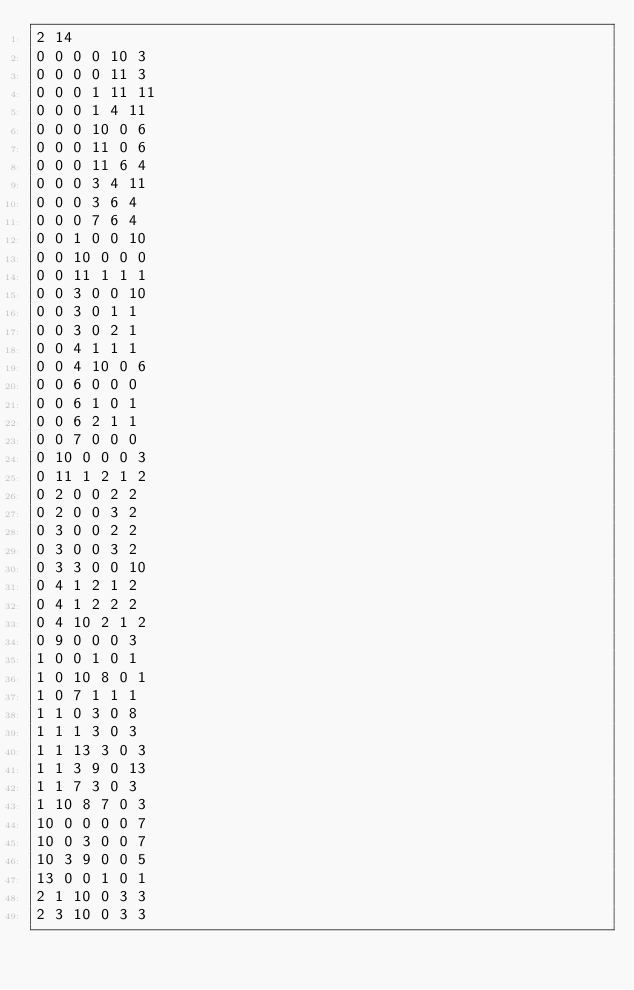<code> <loc_0><loc_0><loc_500><loc_500><_SQL_>2 14
0 0 0 0 10 3
0 0 0 0 11 3
0 0 0 1 11 11
0 0 0 1 4 11
0 0 0 10 0 6
0 0 0 11 0 6
0 0 0 11 6 4
0 0 0 3 4 11
0 0 0 3 6 4
0 0 0 7 6 4
0 0 1 0 0 10
0 0 10 0 0 0
0 0 11 1 1 1
0 0 3 0 0 10
0 0 3 0 1 1
0 0 3 0 2 1
0 0 4 1 1 1
0 0 4 10 0 6
0 0 6 0 0 0
0 0 6 1 0 1
0 0 6 2 1 1
0 0 7 0 0 0
0 10 0 0 0 3
0 11 1 2 1 2
0 2 0 0 2 2
0 2 0 0 3 2
0 3 0 0 2 2
0 3 0 0 3 2
0 3 3 0 0 10
0 4 1 2 1 2
0 4 1 2 2 2
0 4 10 2 1 2
0 9 0 0 0 3
1 0 0 1 0 1
1 0 10 8 0 1
1 0 7 1 1 1
1 1 0 3 0 8
1 1 1 3 0 3
1 1 13 3 0 3
1 1 3 9 0 13
1 1 7 3 0 3
1 10 8 7 0 3
10 0 0 0 0 7
10 0 3 0 0 7
10 3 9 0 0 5
13 0 0 1 0 1
2 1 10 0 3 3
2 3 10 0 3 3</code> 